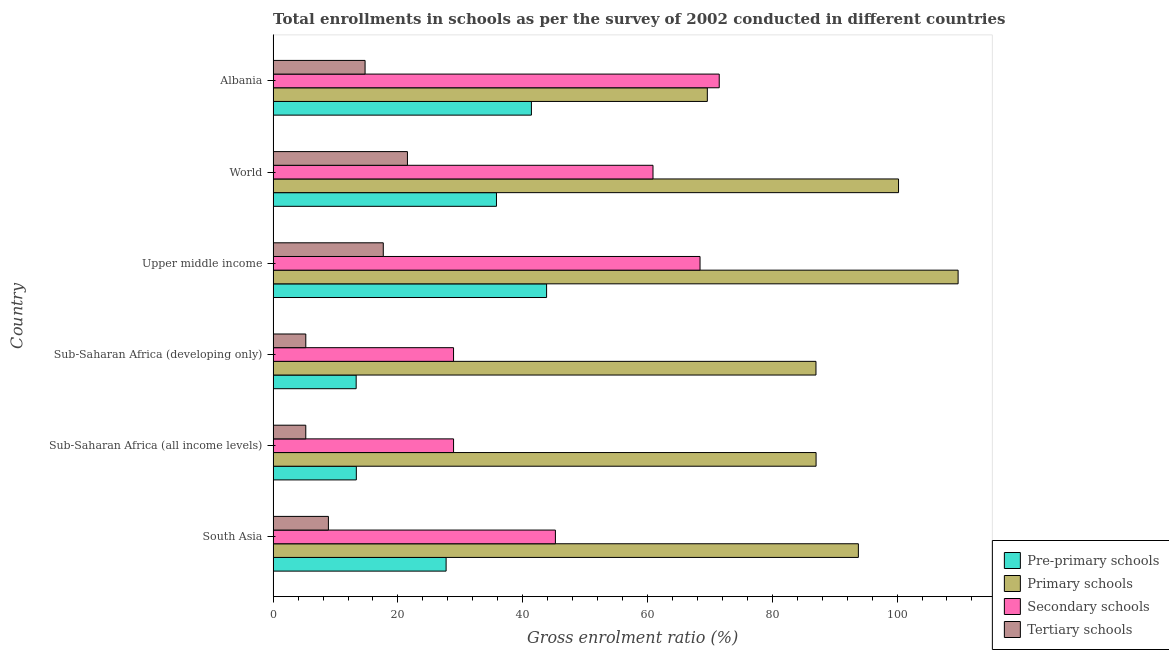How many different coloured bars are there?
Keep it short and to the point. 4. How many groups of bars are there?
Make the answer very short. 6. How many bars are there on the 2nd tick from the bottom?
Ensure brevity in your answer.  4. What is the label of the 1st group of bars from the top?
Keep it short and to the point. Albania. In how many cases, is the number of bars for a given country not equal to the number of legend labels?
Provide a short and direct response. 0. What is the gross enrolment ratio in primary schools in Upper middle income?
Provide a short and direct response. 109.78. Across all countries, what is the maximum gross enrolment ratio in secondary schools?
Your answer should be very brief. 71.5. Across all countries, what is the minimum gross enrolment ratio in secondary schools?
Offer a terse response. 28.92. In which country was the gross enrolment ratio in secondary schools maximum?
Your answer should be compact. Albania. In which country was the gross enrolment ratio in tertiary schools minimum?
Ensure brevity in your answer.  Sub-Saharan Africa (all income levels). What is the total gross enrolment ratio in primary schools in the graph?
Your answer should be very brief. 547.43. What is the difference between the gross enrolment ratio in tertiary schools in South Asia and that in Sub-Saharan Africa (developing only)?
Your answer should be very brief. 3.63. What is the difference between the gross enrolment ratio in primary schools in South Asia and the gross enrolment ratio in tertiary schools in Sub-Saharan Africa (developing only)?
Provide a short and direct response. 88.56. What is the average gross enrolment ratio in primary schools per country?
Provide a short and direct response. 91.24. What is the difference between the gross enrolment ratio in primary schools and gross enrolment ratio in tertiary schools in Sub-Saharan Africa (developing only)?
Provide a succinct answer. 81.77. In how many countries, is the gross enrolment ratio in secondary schools greater than 76 %?
Give a very brief answer. 0. What is the ratio of the gross enrolment ratio in tertiary schools in South Asia to that in Sub-Saharan Africa (developing only)?
Make the answer very short. 1.69. What is the difference between the highest and the second highest gross enrolment ratio in tertiary schools?
Your response must be concise. 3.87. What is the difference between the highest and the lowest gross enrolment ratio in pre-primary schools?
Ensure brevity in your answer.  30.52. In how many countries, is the gross enrolment ratio in secondary schools greater than the average gross enrolment ratio in secondary schools taken over all countries?
Make the answer very short. 3. Is the sum of the gross enrolment ratio in primary schools in South Asia and World greater than the maximum gross enrolment ratio in tertiary schools across all countries?
Provide a short and direct response. Yes. Is it the case that in every country, the sum of the gross enrolment ratio in tertiary schools and gross enrolment ratio in secondary schools is greater than the sum of gross enrolment ratio in primary schools and gross enrolment ratio in pre-primary schools?
Give a very brief answer. No. What does the 2nd bar from the top in Sub-Saharan Africa (developing only) represents?
Offer a very short reply. Secondary schools. What does the 3rd bar from the bottom in World represents?
Provide a short and direct response. Secondary schools. Is it the case that in every country, the sum of the gross enrolment ratio in pre-primary schools and gross enrolment ratio in primary schools is greater than the gross enrolment ratio in secondary schools?
Offer a terse response. Yes. Are all the bars in the graph horizontal?
Your answer should be compact. Yes. What is the difference between two consecutive major ticks on the X-axis?
Keep it short and to the point. 20. How many legend labels are there?
Your answer should be compact. 4. What is the title of the graph?
Your response must be concise. Total enrollments in schools as per the survey of 2002 conducted in different countries. Does "United States" appear as one of the legend labels in the graph?
Give a very brief answer. No. What is the Gross enrolment ratio (%) of Pre-primary schools in South Asia?
Your answer should be very brief. 27.72. What is the Gross enrolment ratio (%) of Primary schools in South Asia?
Your answer should be compact. 93.8. What is the Gross enrolment ratio (%) in Secondary schools in South Asia?
Provide a succinct answer. 45.24. What is the Gross enrolment ratio (%) in Tertiary schools in South Asia?
Offer a very short reply. 8.86. What is the Gross enrolment ratio (%) in Pre-primary schools in Sub-Saharan Africa (all income levels)?
Give a very brief answer. 13.34. What is the Gross enrolment ratio (%) of Primary schools in Sub-Saharan Africa (all income levels)?
Ensure brevity in your answer.  87.02. What is the Gross enrolment ratio (%) of Secondary schools in Sub-Saharan Africa (all income levels)?
Offer a very short reply. 28.92. What is the Gross enrolment ratio (%) of Tertiary schools in Sub-Saharan Africa (all income levels)?
Ensure brevity in your answer.  5.23. What is the Gross enrolment ratio (%) of Pre-primary schools in Sub-Saharan Africa (developing only)?
Ensure brevity in your answer.  13.31. What is the Gross enrolment ratio (%) of Primary schools in Sub-Saharan Africa (developing only)?
Your answer should be compact. 87. What is the Gross enrolment ratio (%) of Secondary schools in Sub-Saharan Africa (developing only)?
Ensure brevity in your answer.  28.92. What is the Gross enrolment ratio (%) of Tertiary schools in Sub-Saharan Africa (developing only)?
Give a very brief answer. 5.24. What is the Gross enrolment ratio (%) of Pre-primary schools in Upper middle income?
Provide a short and direct response. 43.83. What is the Gross enrolment ratio (%) of Primary schools in Upper middle income?
Ensure brevity in your answer.  109.78. What is the Gross enrolment ratio (%) in Secondary schools in Upper middle income?
Provide a short and direct response. 68.42. What is the Gross enrolment ratio (%) of Tertiary schools in Upper middle income?
Give a very brief answer. 17.65. What is the Gross enrolment ratio (%) in Pre-primary schools in World?
Ensure brevity in your answer.  35.8. What is the Gross enrolment ratio (%) of Primary schools in World?
Keep it short and to the point. 100.24. What is the Gross enrolment ratio (%) of Secondary schools in World?
Provide a short and direct response. 60.88. What is the Gross enrolment ratio (%) of Tertiary schools in World?
Ensure brevity in your answer.  21.53. What is the Gross enrolment ratio (%) of Pre-primary schools in Albania?
Offer a terse response. 41.4. What is the Gross enrolment ratio (%) in Primary schools in Albania?
Offer a terse response. 69.59. What is the Gross enrolment ratio (%) of Secondary schools in Albania?
Your response must be concise. 71.5. What is the Gross enrolment ratio (%) of Tertiary schools in Albania?
Keep it short and to the point. 14.74. Across all countries, what is the maximum Gross enrolment ratio (%) of Pre-primary schools?
Provide a succinct answer. 43.83. Across all countries, what is the maximum Gross enrolment ratio (%) in Primary schools?
Ensure brevity in your answer.  109.78. Across all countries, what is the maximum Gross enrolment ratio (%) in Secondary schools?
Your answer should be compact. 71.5. Across all countries, what is the maximum Gross enrolment ratio (%) in Tertiary schools?
Your answer should be compact. 21.53. Across all countries, what is the minimum Gross enrolment ratio (%) in Pre-primary schools?
Keep it short and to the point. 13.31. Across all countries, what is the minimum Gross enrolment ratio (%) of Primary schools?
Provide a short and direct response. 69.59. Across all countries, what is the minimum Gross enrolment ratio (%) in Secondary schools?
Ensure brevity in your answer.  28.92. Across all countries, what is the minimum Gross enrolment ratio (%) in Tertiary schools?
Your answer should be very brief. 5.23. What is the total Gross enrolment ratio (%) in Pre-primary schools in the graph?
Ensure brevity in your answer.  175.39. What is the total Gross enrolment ratio (%) in Primary schools in the graph?
Provide a succinct answer. 547.43. What is the total Gross enrolment ratio (%) of Secondary schools in the graph?
Ensure brevity in your answer.  303.88. What is the total Gross enrolment ratio (%) of Tertiary schools in the graph?
Make the answer very short. 73.25. What is the difference between the Gross enrolment ratio (%) in Pre-primary schools in South Asia and that in Sub-Saharan Africa (all income levels)?
Provide a succinct answer. 14.39. What is the difference between the Gross enrolment ratio (%) of Primary schools in South Asia and that in Sub-Saharan Africa (all income levels)?
Provide a short and direct response. 6.78. What is the difference between the Gross enrolment ratio (%) of Secondary schools in South Asia and that in Sub-Saharan Africa (all income levels)?
Your answer should be compact. 16.32. What is the difference between the Gross enrolment ratio (%) of Tertiary schools in South Asia and that in Sub-Saharan Africa (all income levels)?
Your answer should be very brief. 3.63. What is the difference between the Gross enrolment ratio (%) in Pre-primary schools in South Asia and that in Sub-Saharan Africa (developing only)?
Your response must be concise. 14.41. What is the difference between the Gross enrolment ratio (%) in Primary schools in South Asia and that in Sub-Saharan Africa (developing only)?
Keep it short and to the point. 6.8. What is the difference between the Gross enrolment ratio (%) in Secondary schools in South Asia and that in Sub-Saharan Africa (developing only)?
Your answer should be very brief. 16.32. What is the difference between the Gross enrolment ratio (%) in Tertiary schools in South Asia and that in Sub-Saharan Africa (developing only)?
Your response must be concise. 3.63. What is the difference between the Gross enrolment ratio (%) in Pre-primary schools in South Asia and that in Upper middle income?
Keep it short and to the point. -16.11. What is the difference between the Gross enrolment ratio (%) of Primary schools in South Asia and that in Upper middle income?
Keep it short and to the point. -15.98. What is the difference between the Gross enrolment ratio (%) of Secondary schools in South Asia and that in Upper middle income?
Give a very brief answer. -23.18. What is the difference between the Gross enrolment ratio (%) of Tertiary schools in South Asia and that in Upper middle income?
Ensure brevity in your answer.  -8.79. What is the difference between the Gross enrolment ratio (%) in Pre-primary schools in South Asia and that in World?
Your answer should be very brief. -8.07. What is the difference between the Gross enrolment ratio (%) in Primary schools in South Asia and that in World?
Offer a terse response. -6.44. What is the difference between the Gross enrolment ratio (%) in Secondary schools in South Asia and that in World?
Provide a short and direct response. -15.64. What is the difference between the Gross enrolment ratio (%) of Tertiary schools in South Asia and that in World?
Provide a short and direct response. -12.66. What is the difference between the Gross enrolment ratio (%) of Pre-primary schools in South Asia and that in Albania?
Ensure brevity in your answer.  -13.67. What is the difference between the Gross enrolment ratio (%) in Primary schools in South Asia and that in Albania?
Keep it short and to the point. 24.21. What is the difference between the Gross enrolment ratio (%) of Secondary schools in South Asia and that in Albania?
Provide a short and direct response. -26.26. What is the difference between the Gross enrolment ratio (%) of Tertiary schools in South Asia and that in Albania?
Give a very brief answer. -5.88. What is the difference between the Gross enrolment ratio (%) in Pre-primary schools in Sub-Saharan Africa (all income levels) and that in Sub-Saharan Africa (developing only)?
Your answer should be compact. 0.03. What is the difference between the Gross enrolment ratio (%) of Primary schools in Sub-Saharan Africa (all income levels) and that in Sub-Saharan Africa (developing only)?
Give a very brief answer. 0.02. What is the difference between the Gross enrolment ratio (%) in Secondary schools in Sub-Saharan Africa (all income levels) and that in Sub-Saharan Africa (developing only)?
Provide a short and direct response. 0. What is the difference between the Gross enrolment ratio (%) of Tertiary schools in Sub-Saharan Africa (all income levels) and that in Sub-Saharan Africa (developing only)?
Your response must be concise. -0. What is the difference between the Gross enrolment ratio (%) of Pre-primary schools in Sub-Saharan Africa (all income levels) and that in Upper middle income?
Offer a terse response. -30.49. What is the difference between the Gross enrolment ratio (%) in Primary schools in Sub-Saharan Africa (all income levels) and that in Upper middle income?
Provide a succinct answer. -22.76. What is the difference between the Gross enrolment ratio (%) in Secondary schools in Sub-Saharan Africa (all income levels) and that in Upper middle income?
Make the answer very short. -39.5. What is the difference between the Gross enrolment ratio (%) in Tertiary schools in Sub-Saharan Africa (all income levels) and that in Upper middle income?
Provide a short and direct response. -12.42. What is the difference between the Gross enrolment ratio (%) in Pre-primary schools in Sub-Saharan Africa (all income levels) and that in World?
Ensure brevity in your answer.  -22.46. What is the difference between the Gross enrolment ratio (%) in Primary schools in Sub-Saharan Africa (all income levels) and that in World?
Make the answer very short. -13.22. What is the difference between the Gross enrolment ratio (%) in Secondary schools in Sub-Saharan Africa (all income levels) and that in World?
Your answer should be very brief. -31.96. What is the difference between the Gross enrolment ratio (%) in Tertiary schools in Sub-Saharan Africa (all income levels) and that in World?
Provide a succinct answer. -16.29. What is the difference between the Gross enrolment ratio (%) in Pre-primary schools in Sub-Saharan Africa (all income levels) and that in Albania?
Offer a terse response. -28.06. What is the difference between the Gross enrolment ratio (%) in Primary schools in Sub-Saharan Africa (all income levels) and that in Albania?
Give a very brief answer. 17.43. What is the difference between the Gross enrolment ratio (%) of Secondary schools in Sub-Saharan Africa (all income levels) and that in Albania?
Ensure brevity in your answer.  -42.58. What is the difference between the Gross enrolment ratio (%) in Tertiary schools in Sub-Saharan Africa (all income levels) and that in Albania?
Keep it short and to the point. -9.5. What is the difference between the Gross enrolment ratio (%) in Pre-primary schools in Sub-Saharan Africa (developing only) and that in Upper middle income?
Your answer should be very brief. -30.52. What is the difference between the Gross enrolment ratio (%) of Primary schools in Sub-Saharan Africa (developing only) and that in Upper middle income?
Keep it short and to the point. -22.78. What is the difference between the Gross enrolment ratio (%) in Secondary schools in Sub-Saharan Africa (developing only) and that in Upper middle income?
Ensure brevity in your answer.  -39.51. What is the difference between the Gross enrolment ratio (%) in Tertiary schools in Sub-Saharan Africa (developing only) and that in Upper middle income?
Your answer should be very brief. -12.42. What is the difference between the Gross enrolment ratio (%) in Pre-primary schools in Sub-Saharan Africa (developing only) and that in World?
Provide a succinct answer. -22.49. What is the difference between the Gross enrolment ratio (%) in Primary schools in Sub-Saharan Africa (developing only) and that in World?
Ensure brevity in your answer.  -13.23. What is the difference between the Gross enrolment ratio (%) in Secondary schools in Sub-Saharan Africa (developing only) and that in World?
Give a very brief answer. -31.97. What is the difference between the Gross enrolment ratio (%) in Tertiary schools in Sub-Saharan Africa (developing only) and that in World?
Your answer should be very brief. -16.29. What is the difference between the Gross enrolment ratio (%) in Pre-primary schools in Sub-Saharan Africa (developing only) and that in Albania?
Your answer should be very brief. -28.09. What is the difference between the Gross enrolment ratio (%) of Primary schools in Sub-Saharan Africa (developing only) and that in Albania?
Give a very brief answer. 17.41. What is the difference between the Gross enrolment ratio (%) of Secondary schools in Sub-Saharan Africa (developing only) and that in Albania?
Provide a short and direct response. -42.58. What is the difference between the Gross enrolment ratio (%) of Tertiary schools in Sub-Saharan Africa (developing only) and that in Albania?
Offer a terse response. -9.5. What is the difference between the Gross enrolment ratio (%) of Pre-primary schools in Upper middle income and that in World?
Provide a succinct answer. 8.04. What is the difference between the Gross enrolment ratio (%) in Primary schools in Upper middle income and that in World?
Provide a succinct answer. 9.55. What is the difference between the Gross enrolment ratio (%) in Secondary schools in Upper middle income and that in World?
Keep it short and to the point. 7.54. What is the difference between the Gross enrolment ratio (%) of Tertiary schools in Upper middle income and that in World?
Your answer should be compact. -3.87. What is the difference between the Gross enrolment ratio (%) in Pre-primary schools in Upper middle income and that in Albania?
Keep it short and to the point. 2.43. What is the difference between the Gross enrolment ratio (%) in Primary schools in Upper middle income and that in Albania?
Your response must be concise. 40.19. What is the difference between the Gross enrolment ratio (%) of Secondary schools in Upper middle income and that in Albania?
Give a very brief answer. -3.08. What is the difference between the Gross enrolment ratio (%) of Tertiary schools in Upper middle income and that in Albania?
Ensure brevity in your answer.  2.92. What is the difference between the Gross enrolment ratio (%) of Pre-primary schools in World and that in Albania?
Your answer should be compact. -5.6. What is the difference between the Gross enrolment ratio (%) of Primary schools in World and that in Albania?
Your response must be concise. 30.64. What is the difference between the Gross enrolment ratio (%) in Secondary schools in World and that in Albania?
Provide a short and direct response. -10.62. What is the difference between the Gross enrolment ratio (%) of Tertiary schools in World and that in Albania?
Offer a terse response. 6.79. What is the difference between the Gross enrolment ratio (%) in Pre-primary schools in South Asia and the Gross enrolment ratio (%) in Primary schools in Sub-Saharan Africa (all income levels)?
Provide a succinct answer. -59.3. What is the difference between the Gross enrolment ratio (%) of Pre-primary schools in South Asia and the Gross enrolment ratio (%) of Secondary schools in Sub-Saharan Africa (all income levels)?
Keep it short and to the point. -1.2. What is the difference between the Gross enrolment ratio (%) of Pre-primary schools in South Asia and the Gross enrolment ratio (%) of Tertiary schools in Sub-Saharan Africa (all income levels)?
Give a very brief answer. 22.49. What is the difference between the Gross enrolment ratio (%) in Primary schools in South Asia and the Gross enrolment ratio (%) in Secondary schools in Sub-Saharan Africa (all income levels)?
Keep it short and to the point. 64.88. What is the difference between the Gross enrolment ratio (%) in Primary schools in South Asia and the Gross enrolment ratio (%) in Tertiary schools in Sub-Saharan Africa (all income levels)?
Your answer should be compact. 88.56. What is the difference between the Gross enrolment ratio (%) in Secondary schools in South Asia and the Gross enrolment ratio (%) in Tertiary schools in Sub-Saharan Africa (all income levels)?
Make the answer very short. 40.01. What is the difference between the Gross enrolment ratio (%) of Pre-primary schools in South Asia and the Gross enrolment ratio (%) of Primary schools in Sub-Saharan Africa (developing only)?
Provide a succinct answer. -59.28. What is the difference between the Gross enrolment ratio (%) in Pre-primary schools in South Asia and the Gross enrolment ratio (%) in Secondary schools in Sub-Saharan Africa (developing only)?
Ensure brevity in your answer.  -1.19. What is the difference between the Gross enrolment ratio (%) in Pre-primary schools in South Asia and the Gross enrolment ratio (%) in Tertiary schools in Sub-Saharan Africa (developing only)?
Your answer should be very brief. 22.49. What is the difference between the Gross enrolment ratio (%) of Primary schools in South Asia and the Gross enrolment ratio (%) of Secondary schools in Sub-Saharan Africa (developing only)?
Give a very brief answer. 64.88. What is the difference between the Gross enrolment ratio (%) of Primary schools in South Asia and the Gross enrolment ratio (%) of Tertiary schools in Sub-Saharan Africa (developing only)?
Offer a very short reply. 88.56. What is the difference between the Gross enrolment ratio (%) in Secondary schools in South Asia and the Gross enrolment ratio (%) in Tertiary schools in Sub-Saharan Africa (developing only)?
Ensure brevity in your answer.  40.01. What is the difference between the Gross enrolment ratio (%) in Pre-primary schools in South Asia and the Gross enrolment ratio (%) in Primary schools in Upper middle income?
Your answer should be very brief. -82.06. What is the difference between the Gross enrolment ratio (%) in Pre-primary schools in South Asia and the Gross enrolment ratio (%) in Secondary schools in Upper middle income?
Make the answer very short. -40.7. What is the difference between the Gross enrolment ratio (%) in Pre-primary schools in South Asia and the Gross enrolment ratio (%) in Tertiary schools in Upper middle income?
Offer a terse response. 10.07. What is the difference between the Gross enrolment ratio (%) in Primary schools in South Asia and the Gross enrolment ratio (%) in Secondary schools in Upper middle income?
Ensure brevity in your answer.  25.38. What is the difference between the Gross enrolment ratio (%) in Primary schools in South Asia and the Gross enrolment ratio (%) in Tertiary schools in Upper middle income?
Offer a terse response. 76.14. What is the difference between the Gross enrolment ratio (%) in Secondary schools in South Asia and the Gross enrolment ratio (%) in Tertiary schools in Upper middle income?
Ensure brevity in your answer.  27.59. What is the difference between the Gross enrolment ratio (%) of Pre-primary schools in South Asia and the Gross enrolment ratio (%) of Primary schools in World?
Keep it short and to the point. -72.51. What is the difference between the Gross enrolment ratio (%) in Pre-primary schools in South Asia and the Gross enrolment ratio (%) in Secondary schools in World?
Keep it short and to the point. -33.16. What is the difference between the Gross enrolment ratio (%) of Pre-primary schools in South Asia and the Gross enrolment ratio (%) of Tertiary schools in World?
Provide a short and direct response. 6.2. What is the difference between the Gross enrolment ratio (%) of Primary schools in South Asia and the Gross enrolment ratio (%) of Secondary schools in World?
Offer a terse response. 32.92. What is the difference between the Gross enrolment ratio (%) in Primary schools in South Asia and the Gross enrolment ratio (%) in Tertiary schools in World?
Keep it short and to the point. 72.27. What is the difference between the Gross enrolment ratio (%) in Secondary schools in South Asia and the Gross enrolment ratio (%) in Tertiary schools in World?
Your response must be concise. 23.72. What is the difference between the Gross enrolment ratio (%) of Pre-primary schools in South Asia and the Gross enrolment ratio (%) of Primary schools in Albania?
Ensure brevity in your answer.  -41.87. What is the difference between the Gross enrolment ratio (%) in Pre-primary schools in South Asia and the Gross enrolment ratio (%) in Secondary schools in Albania?
Your answer should be compact. -43.77. What is the difference between the Gross enrolment ratio (%) in Pre-primary schools in South Asia and the Gross enrolment ratio (%) in Tertiary schools in Albania?
Ensure brevity in your answer.  12.99. What is the difference between the Gross enrolment ratio (%) of Primary schools in South Asia and the Gross enrolment ratio (%) of Secondary schools in Albania?
Your answer should be compact. 22.3. What is the difference between the Gross enrolment ratio (%) of Primary schools in South Asia and the Gross enrolment ratio (%) of Tertiary schools in Albania?
Your answer should be very brief. 79.06. What is the difference between the Gross enrolment ratio (%) of Secondary schools in South Asia and the Gross enrolment ratio (%) of Tertiary schools in Albania?
Your answer should be very brief. 30.5. What is the difference between the Gross enrolment ratio (%) of Pre-primary schools in Sub-Saharan Africa (all income levels) and the Gross enrolment ratio (%) of Primary schools in Sub-Saharan Africa (developing only)?
Make the answer very short. -73.67. What is the difference between the Gross enrolment ratio (%) of Pre-primary schools in Sub-Saharan Africa (all income levels) and the Gross enrolment ratio (%) of Secondary schools in Sub-Saharan Africa (developing only)?
Offer a terse response. -15.58. What is the difference between the Gross enrolment ratio (%) in Pre-primary schools in Sub-Saharan Africa (all income levels) and the Gross enrolment ratio (%) in Tertiary schools in Sub-Saharan Africa (developing only)?
Make the answer very short. 8.1. What is the difference between the Gross enrolment ratio (%) in Primary schools in Sub-Saharan Africa (all income levels) and the Gross enrolment ratio (%) in Secondary schools in Sub-Saharan Africa (developing only)?
Your answer should be very brief. 58.1. What is the difference between the Gross enrolment ratio (%) of Primary schools in Sub-Saharan Africa (all income levels) and the Gross enrolment ratio (%) of Tertiary schools in Sub-Saharan Africa (developing only)?
Offer a very short reply. 81.78. What is the difference between the Gross enrolment ratio (%) in Secondary schools in Sub-Saharan Africa (all income levels) and the Gross enrolment ratio (%) in Tertiary schools in Sub-Saharan Africa (developing only)?
Keep it short and to the point. 23.68. What is the difference between the Gross enrolment ratio (%) in Pre-primary schools in Sub-Saharan Africa (all income levels) and the Gross enrolment ratio (%) in Primary schools in Upper middle income?
Ensure brevity in your answer.  -96.45. What is the difference between the Gross enrolment ratio (%) in Pre-primary schools in Sub-Saharan Africa (all income levels) and the Gross enrolment ratio (%) in Secondary schools in Upper middle income?
Offer a terse response. -55.09. What is the difference between the Gross enrolment ratio (%) in Pre-primary schools in Sub-Saharan Africa (all income levels) and the Gross enrolment ratio (%) in Tertiary schools in Upper middle income?
Give a very brief answer. -4.32. What is the difference between the Gross enrolment ratio (%) of Primary schools in Sub-Saharan Africa (all income levels) and the Gross enrolment ratio (%) of Secondary schools in Upper middle income?
Offer a terse response. 18.6. What is the difference between the Gross enrolment ratio (%) of Primary schools in Sub-Saharan Africa (all income levels) and the Gross enrolment ratio (%) of Tertiary schools in Upper middle income?
Your response must be concise. 69.36. What is the difference between the Gross enrolment ratio (%) of Secondary schools in Sub-Saharan Africa (all income levels) and the Gross enrolment ratio (%) of Tertiary schools in Upper middle income?
Provide a short and direct response. 11.27. What is the difference between the Gross enrolment ratio (%) of Pre-primary schools in Sub-Saharan Africa (all income levels) and the Gross enrolment ratio (%) of Primary schools in World?
Your answer should be compact. -86.9. What is the difference between the Gross enrolment ratio (%) in Pre-primary schools in Sub-Saharan Africa (all income levels) and the Gross enrolment ratio (%) in Secondary schools in World?
Offer a terse response. -47.55. What is the difference between the Gross enrolment ratio (%) of Pre-primary schools in Sub-Saharan Africa (all income levels) and the Gross enrolment ratio (%) of Tertiary schools in World?
Provide a short and direct response. -8.19. What is the difference between the Gross enrolment ratio (%) in Primary schools in Sub-Saharan Africa (all income levels) and the Gross enrolment ratio (%) in Secondary schools in World?
Provide a short and direct response. 26.14. What is the difference between the Gross enrolment ratio (%) in Primary schools in Sub-Saharan Africa (all income levels) and the Gross enrolment ratio (%) in Tertiary schools in World?
Make the answer very short. 65.49. What is the difference between the Gross enrolment ratio (%) of Secondary schools in Sub-Saharan Africa (all income levels) and the Gross enrolment ratio (%) of Tertiary schools in World?
Your response must be concise. 7.39. What is the difference between the Gross enrolment ratio (%) in Pre-primary schools in Sub-Saharan Africa (all income levels) and the Gross enrolment ratio (%) in Primary schools in Albania?
Ensure brevity in your answer.  -56.26. What is the difference between the Gross enrolment ratio (%) in Pre-primary schools in Sub-Saharan Africa (all income levels) and the Gross enrolment ratio (%) in Secondary schools in Albania?
Provide a succinct answer. -58.16. What is the difference between the Gross enrolment ratio (%) of Pre-primary schools in Sub-Saharan Africa (all income levels) and the Gross enrolment ratio (%) of Tertiary schools in Albania?
Provide a short and direct response. -1.4. What is the difference between the Gross enrolment ratio (%) of Primary schools in Sub-Saharan Africa (all income levels) and the Gross enrolment ratio (%) of Secondary schools in Albania?
Keep it short and to the point. 15.52. What is the difference between the Gross enrolment ratio (%) in Primary schools in Sub-Saharan Africa (all income levels) and the Gross enrolment ratio (%) in Tertiary schools in Albania?
Offer a terse response. 72.28. What is the difference between the Gross enrolment ratio (%) of Secondary schools in Sub-Saharan Africa (all income levels) and the Gross enrolment ratio (%) of Tertiary schools in Albania?
Keep it short and to the point. 14.18. What is the difference between the Gross enrolment ratio (%) in Pre-primary schools in Sub-Saharan Africa (developing only) and the Gross enrolment ratio (%) in Primary schools in Upper middle income?
Offer a very short reply. -96.47. What is the difference between the Gross enrolment ratio (%) of Pre-primary schools in Sub-Saharan Africa (developing only) and the Gross enrolment ratio (%) of Secondary schools in Upper middle income?
Provide a short and direct response. -55.11. What is the difference between the Gross enrolment ratio (%) of Pre-primary schools in Sub-Saharan Africa (developing only) and the Gross enrolment ratio (%) of Tertiary schools in Upper middle income?
Your answer should be very brief. -4.34. What is the difference between the Gross enrolment ratio (%) of Primary schools in Sub-Saharan Africa (developing only) and the Gross enrolment ratio (%) of Secondary schools in Upper middle income?
Your answer should be compact. 18.58. What is the difference between the Gross enrolment ratio (%) of Primary schools in Sub-Saharan Africa (developing only) and the Gross enrolment ratio (%) of Tertiary schools in Upper middle income?
Your response must be concise. 69.35. What is the difference between the Gross enrolment ratio (%) in Secondary schools in Sub-Saharan Africa (developing only) and the Gross enrolment ratio (%) in Tertiary schools in Upper middle income?
Offer a terse response. 11.26. What is the difference between the Gross enrolment ratio (%) in Pre-primary schools in Sub-Saharan Africa (developing only) and the Gross enrolment ratio (%) in Primary schools in World?
Provide a succinct answer. -86.93. What is the difference between the Gross enrolment ratio (%) of Pre-primary schools in Sub-Saharan Africa (developing only) and the Gross enrolment ratio (%) of Secondary schools in World?
Provide a succinct answer. -47.57. What is the difference between the Gross enrolment ratio (%) of Pre-primary schools in Sub-Saharan Africa (developing only) and the Gross enrolment ratio (%) of Tertiary schools in World?
Give a very brief answer. -8.22. What is the difference between the Gross enrolment ratio (%) in Primary schools in Sub-Saharan Africa (developing only) and the Gross enrolment ratio (%) in Secondary schools in World?
Provide a short and direct response. 26.12. What is the difference between the Gross enrolment ratio (%) in Primary schools in Sub-Saharan Africa (developing only) and the Gross enrolment ratio (%) in Tertiary schools in World?
Provide a short and direct response. 65.48. What is the difference between the Gross enrolment ratio (%) in Secondary schools in Sub-Saharan Africa (developing only) and the Gross enrolment ratio (%) in Tertiary schools in World?
Offer a very short reply. 7.39. What is the difference between the Gross enrolment ratio (%) in Pre-primary schools in Sub-Saharan Africa (developing only) and the Gross enrolment ratio (%) in Primary schools in Albania?
Keep it short and to the point. -56.28. What is the difference between the Gross enrolment ratio (%) of Pre-primary schools in Sub-Saharan Africa (developing only) and the Gross enrolment ratio (%) of Secondary schools in Albania?
Provide a short and direct response. -58.19. What is the difference between the Gross enrolment ratio (%) of Pre-primary schools in Sub-Saharan Africa (developing only) and the Gross enrolment ratio (%) of Tertiary schools in Albania?
Provide a short and direct response. -1.43. What is the difference between the Gross enrolment ratio (%) of Primary schools in Sub-Saharan Africa (developing only) and the Gross enrolment ratio (%) of Secondary schools in Albania?
Give a very brief answer. 15.5. What is the difference between the Gross enrolment ratio (%) of Primary schools in Sub-Saharan Africa (developing only) and the Gross enrolment ratio (%) of Tertiary schools in Albania?
Keep it short and to the point. 72.26. What is the difference between the Gross enrolment ratio (%) in Secondary schools in Sub-Saharan Africa (developing only) and the Gross enrolment ratio (%) in Tertiary schools in Albania?
Keep it short and to the point. 14.18. What is the difference between the Gross enrolment ratio (%) in Pre-primary schools in Upper middle income and the Gross enrolment ratio (%) in Primary schools in World?
Ensure brevity in your answer.  -56.41. What is the difference between the Gross enrolment ratio (%) in Pre-primary schools in Upper middle income and the Gross enrolment ratio (%) in Secondary schools in World?
Provide a succinct answer. -17.05. What is the difference between the Gross enrolment ratio (%) of Pre-primary schools in Upper middle income and the Gross enrolment ratio (%) of Tertiary schools in World?
Your answer should be compact. 22.3. What is the difference between the Gross enrolment ratio (%) in Primary schools in Upper middle income and the Gross enrolment ratio (%) in Secondary schools in World?
Offer a very short reply. 48.9. What is the difference between the Gross enrolment ratio (%) in Primary schools in Upper middle income and the Gross enrolment ratio (%) in Tertiary schools in World?
Your answer should be very brief. 88.26. What is the difference between the Gross enrolment ratio (%) in Secondary schools in Upper middle income and the Gross enrolment ratio (%) in Tertiary schools in World?
Keep it short and to the point. 46.9. What is the difference between the Gross enrolment ratio (%) of Pre-primary schools in Upper middle income and the Gross enrolment ratio (%) of Primary schools in Albania?
Your response must be concise. -25.76. What is the difference between the Gross enrolment ratio (%) in Pre-primary schools in Upper middle income and the Gross enrolment ratio (%) in Secondary schools in Albania?
Your answer should be very brief. -27.67. What is the difference between the Gross enrolment ratio (%) of Pre-primary schools in Upper middle income and the Gross enrolment ratio (%) of Tertiary schools in Albania?
Offer a terse response. 29.09. What is the difference between the Gross enrolment ratio (%) in Primary schools in Upper middle income and the Gross enrolment ratio (%) in Secondary schools in Albania?
Your answer should be very brief. 38.28. What is the difference between the Gross enrolment ratio (%) of Primary schools in Upper middle income and the Gross enrolment ratio (%) of Tertiary schools in Albania?
Give a very brief answer. 95.04. What is the difference between the Gross enrolment ratio (%) of Secondary schools in Upper middle income and the Gross enrolment ratio (%) of Tertiary schools in Albania?
Give a very brief answer. 53.68. What is the difference between the Gross enrolment ratio (%) of Pre-primary schools in World and the Gross enrolment ratio (%) of Primary schools in Albania?
Offer a terse response. -33.8. What is the difference between the Gross enrolment ratio (%) of Pre-primary schools in World and the Gross enrolment ratio (%) of Secondary schools in Albania?
Provide a short and direct response. -35.7. What is the difference between the Gross enrolment ratio (%) of Pre-primary schools in World and the Gross enrolment ratio (%) of Tertiary schools in Albania?
Keep it short and to the point. 21.06. What is the difference between the Gross enrolment ratio (%) of Primary schools in World and the Gross enrolment ratio (%) of Secondary schools in Albania?
Your answer should be compact. 28.74. What is the difference between the Gross enrolment ratio (%) of Primary schools in World and the Gross enrolment ratio (%) of Tertiary schools in Albania?
Offer a very short reply. 85.5. What is the difference between the Gross enrolment ratio (%) of Secondary schools in World and the Gross enrolment ratio (%) of Tertiary schools in Albania?
Offer a terse response. 46.14. What is the average Gross enrolment ratio (%) of Pre-primary schools per country?
Offer a very short reply. 29.23. What is the average Gross enrolment ratio (%) in Primary schools per country?
Your answer should be very brief. 91.24. What is the average Gross enrolment ratio (%) in Secondary schools per country?
Provide a succinct answer. 50.65. What is the average Gross enrolment ratio (%) of Tertiary schools per country?
Ensure brevity in your answer.  12.21. What is the difference between the Gross enrolment ratio (%) in Pre-primary schools and Gross enrolment ratio (%) in Primary schools in South Asia?
Provide a succinct answer. -66.08. What is the difference between the Gross enrolment ratio (%) in Pre-primary schools and Gross enrolment ratio (%) in Secondary schools in South Asia?
Provide a succinct answer. -17.52. What is the difference between the Gross enrolment ratio (%) of Pre-primary schools and Gross enrolment ratio (%) of Tertiary schools in South Asia?
Ensure brevity in your answer.  18.86. What is the difference between the Gross enrolment ratio (%) in Primary schools and Gross enrolment ratio (%) in Secondary schools in South Asia?
Keep it short and to the point. 48.56. What is the difference between the Gross enrolment ratio (%) in Primary schools and Gross enrolment ratio (%) in Tertiary schools in South Asia?
Provide a succinct answer. 84.94. What is the difference between the Gross enrolment ratio (%) of Secondary schools and Gross enrolment ratio (%) of Tertiary schools in South Asia?
Offer a very short reply. 36.38. What is the difference between the Gross enrolment ratio (%) in Pre-primary schools and Gross enrolment ratio (%) in Primary schools in Sub-Saharan Africa (all income levels)?
Offer a very short reply. -73.68. What is the difference between the Gross enrolment ratio (%) in Pre-primary schools and Gross enrolment ratio (%) in Secondary schools in Sub-Saharan Africa (all income levels)?
Your answer should be compact. -15.58. What is the difference between the Gross enrolment ratio (%) of Pre-primary schools and Gross enrolment ratio (%) of Tertiary schools in Sub-Saharan Africa (all income levels)?
Give a very brief answer. 8.1. What is the difference between the Gross enrolment ratio (%) of Primary schools and Gross enrolment ratio (%) of Secondary schools in Sub-Saharan Africa (all income levels)?
Offer a terse response. 58.1. What is the difference between the Gross enrolment ratio (%) of Primary schools and Gross enrolment ratio (%) of Tertiary schools in Sub-Saharan Africa (all income levels)?
Provide a succinct answer. 81.78. What is the difference between the Gross enrolment ratio (%) of Secondary schools and Gross enrolment ratio (%) of Tertiary schools in Sub-Saharan Africa (all income levels)?
Offer a very short reply. 23.69. What is the difference between the Gross enrolment ratio (%) in Pre-primary schools and Gross enrolment ratio (%) in Primary schools in Sub-Saharan Africa (developing only)?
Offer a terse response. -73.69. What is the difference between the Gross enrolment ratio (%) in Pre-primary schools and Gross enrolment ratio (%) in Secondary schools in Sub-Saharan Africa (developing only)?
Your answer should be very brief. -15.61. What is the difference between the Gross enrolment ratio (%) in Pre-primary schools and Gross enrolment ratio (%) in Tertiary schools in Sub-Saharan Africa (developing only)?
Keep it short and to the point. 8.07. What is the difference between the Gross enrolment ratio (%) of Primary schools and Gross enrolment ratio (%) of Secondary schools in Sub-Saharan Africa (developing only)?
Ensure brevity in your answer.  58.09. What is the difference between the Gross enrolment ratio (%) of Primary schools and Gross enrolment ratio (%) of Tertiary schools in Sub-Saharan Africa (developing only)?
Keep it short and to the point. 81.77. What is the difference between the Gross enrolment ratio (%) in Secondary schools and Gross enrolment ratio (%) in Tertiary schools in Sub-Saharan Africa (developing only)?
Your response must be concise. 23.68. What is the difference between the Gross enrolment ratio (%) of Pre-primary schools and Gross enrolment ratio (%) of Primary schools in Upper middle income?
Provide a succinct answer. -65.95. What is the difference between the Gross enrolment ratio (%) in Pre-primary schools and Gross enrolment ratio (%) in Secondary schools in Upper middle income?
Your answer should be compact. -24.59. What is the difference between the Gross enrolment ratio (%) of Pre-primary schools and Gross enrolment ratio (%) of Tertiary schools in Upper middle income?
Ensure brevity in your answer.  26.18. What is the difference between the Gross enrolment ratio (%) in Primary schools and Gross enrolment ratio (%) in Secondary schools in Upper middle income?
Ensure brevity in your answer.  41.36. What is the difference between the Gross enrolment ratio (%) in Primary schools and Gross enrolment ratio (%) in Tertiary schools in Upper middle income?
Offer a very short reply. 92.13. What is the difference between the Gross enrolment ratio (%) of Secondary schools and Gross enrolment ratio (%) of Tertiary schools in Upper middle income?
Ensure brevity in your answer.  50.77. What is the difference between the Gross enrolment ratio (%) in Pre-primary schools and Gross enrolment ratio (%) in Primary schools in World?
Give a very brief answer. -64.44. What is the difference between the Gross enrolment ratio (%) of Pre-primary schools and Gross enrolment ratio (%) of Secondary schools in World?
Give a very brief answer. -25.09. What is the difference between the Gross enrolment ratio (%) in Pre-primary schools and Gross enrolment ratio (%) in Tertiary schools in World?
Offer a terse response. 14.27. What is the difference between the Gross enrolment ratio (%) of Primary schools and Gross enrolment ratio (%) of Secondary schools in World?
Provide a short and direct response. 39.35. What is the difference between the Gross enrolment ratio (%) of Primary schools and Gross enrolment ratio (%) of Tertiary schools in World?
Make the answer very short. 78.71. What is the difference between the Gross enrolment ratio (%) in Secondary schools and Gross enrolment ratio (%) in Tertiary schools in World?
Ensure brevity in your answer.  39.36. What is the difference between the Gross enrolment ratio (%) of Pre-primary schools and Gross enrolment ratio (%) of Primary schools in Albania?
Provide a short and direct response. -28.2. What is the difference between the Gross enrolment ratio (%) of Pre-primary schools and Gross enrolment ratio (%) of Secondary schools in Albania?
Give a very brief answer. -30.1. What is the difference between the Gross enrolment ratio (%) in Pre-primary schools and Gross enrolment ratio (%) in Tertiary schools in Albania?
Keep it short and to the point. 26.66. What is the difference between the Gross enrolment ratio (%) in Primary schools and Gross enrolment ratio (%) in Secondary schools in Albania?
Provide a succinct answer. -1.91. What is the difference between the Gross enrolment ratio (%) in Primary schools and Gross enrolment ratio (%) in Tertiary schools in Albania?
Ensure brevity in your answer.  54.85. What is the difference between the Gross enrolment ratio (%) in Secondary schools and Gross enrolment ratio (%) in Tertiary schools in Albania?
Offer a terse response. 56.76. What is the ratio of the Gross enrolment ratio (%) of Pre-primary schools in South Asia to that in Sub-Saharan Africa (all income levels)?
Ensure brevity in your answer.  2.08. What is the ratio of the Gross enrolment ratio (%) in Primary schools in South Asia to that in Sub-Saharan Africa (all income levels)?
Your answer should be compact. 1.08. What is the ratio of the Gross enrolment ratio (%) of Secondary schools in South Asia to that in Sub-Saharan Africa (all income levels)?
Make the answer very short. 1.56. What is the ratio of the Gross enrolment ratio (%) in Tertiary schools in South Asia to that in Sub-Saharan Africa (all income levels)?
Offer a terse response. 1.69. What is the ratio of the Gross enrolment ratio (%) in Pre-primary schools in South Asia to that in Sub-Saharan Africa (developing only)?
Provide a succinct answer. 2.08. What is the ratio of the Gross enrolment ratio (%) in Primary schools in South Asia to that in Sub-Saharan Africa (developing only)?
Offer a very short reply. 1.08. What is the ratio of the Gross enrolment ratio (%) in Secondary schools in South Asia to that in Sub-Saharan Africa (developing only)?
Provide a short and direct response. 1.56. What is the ratio of the Gross enrolment ratio (%) of Tertiary schools in South Asia to that in Sub-Saharan Africa (developing only)?
Your response must be concise. 1.69. What is the ratio of the Gross enrolment ratio (%) of Pre-primary schools in South Asia to that in Upper middle income?
Ensure brevity in your answer.  0.63. What is the ratio of the Gross enrolment ratio (%) of Primary schools in South Asia to that in Upper middle income?
Offer a terse response. 0.85. What is the ratio of the Gross enrolment ratio (%) in Secondary schools in South Asia to that in Upper middle income?
Ensure brevity in your answer.  0.66. What is the ratio of the Gross enrolment ratio (%) of Tertiary schools in South Asia to that in Upper middle income?
Give a very brief answer. 0.5. What is the ratio of the Gross enrolment ratio (%) of Pre-primary schools in South Asia to that in World?
Offer a terse response. 0.77. What is the ratio of the Gross enrolment ratio (%) in Primary schools in South Asia to that in World?
Your response must be concise. 0.94. What is the ratio of the Gross enrolment ratio (%) of Secondary schools in South Asia to that in World?
Provide a short and direct response. 0.74. What is the ratio of the Gross enrolment ratio (%) of Tertiary schools in South Asia to that in World?
Your answer should be very brief. 0.41. What is the ratio of the Gross enrolment ratio (%) of Pre-primary schools in South Asia to that in Albania?
Keep it short and to the point. 0.67. What is the ratio of the Gross enrolment ratio (%) in Primary schools in South Asia to that in Albania?
Provide a succinct answer. 1.35. What is the ratio of the Gross enrolment ratio (%) in Secondary schools in South Asia to that in Albania?
Keep it short and to the point. 0.63. What is the ratio of the Gross enrolment ratio (%) in Tertiary schools in South Asia to that in Albania?
Offer a very short reply. 0.6. What is the ratio of the Gross enrolment ratio (%) in Pre-primary schools in Sub-Saharan Africa (all income levels) to that in Sub-Saharan Africa (developing only)?
Your response must be concise. 1. What is the ratio of the Gross enrolment ratio (%) in Pre-primary schools in Sub-Saharan Africa (all income levels) to that in Upper middle income?
Offer a very short reply. 0.3. What is the ratio of the Gross enrolment ratio (%) of Primary schools in Sub-Saharan Africa (all income levels) to that in Upper middle income?
Ensure brevity in your answer.  0.79. What is the ratio of the Gross enrolment ratio (%) in Secondary schools in Sub-Saharan Africa (all income levels) to that in Upper middle income?
Your answer should be compact. 0.42. What is the ratio of the Gross enrolment ratio (%) in Tertiary schools in Sub-Saharan Africa (all income levels) to that in Upper middle income?
Your answer should be compact. 0.3. What is the ratio of the Gross enrolment ratio (%) in Pre-primary schools in Sub-Saharan Africa (all income levels) to that in World?
Provide a short and direct response. 0.37. What is the ratio of the Gross enrolment ratio (%) in Primary schools in Sub-Saharan Africa (all income levels) to that in World?
Your answer should be compact. 0.87. What is the ratio of the Gross enrolment ratio (%) in Secondary schools in Sub-Saharan Africa (all income levels) to that in World?
Your answer should be compact. 0.47. What is the ratio of the Gross enrolment ratio (%) in Tertiary schools in Sub-Saharan Africa (all income levels) to that in World?
Give a very brief answer. 0.24. What is the ratio of the Gross enrolment ratio (%) of Pre-primary schools in Sub-Saharan Africa (all income levels) to that in Albania?
Your response must be concise. 0.32. What is the ratio of the Gross enrolment ratio (%) in Primary schools in Sub-Saharan Africa (all income levels) to that in Albania?
Provide a succinct answer. 1.25. What is the ratio of the Gross enrolment ratio (%) of Secondary schools in Sub-Saharan Africa (all income levels) to that in Albania?
Your answer should be compact. 0.4. What is the ratio of the Gross enrolment ratio (%) in Tertiary schools in Sub-Saharan Africa (all income levels) to that in Albania?
Your answer should be very brief. 0.36. What is the ratio of the Gross enrolment ratio (%) in Pre-primary schools in Sub-Saharan Africa (developing only) to that in Upper middle income?
Provide a succinct answer. 0.3. What is the ratio of the Gross enrolment ratio (%) in Primary schools in Sub-Saharan Africa (developing only) to that in Upper middle income?
Your response must be concise. 0.79. What is the ratio of the Gross enrolment ratio (%) in Secondary schools in Sub-Saharan Africa (developing only) to that in Upper middle income?
Ensure brevity in your answer.  0.42. What is the ratio of the Gross enrolment ratio (%) of Tertiary schools in Sub-Saharan Africa (developing only) to that in Upper middle income?
Ensure brevity in your answer.  0.3. What is the ratio of the Gross enrolment ratio (%) of Pre-primary schools in Sub-Saharan Africa (developing only) to that in World?
Your response must be concise. 0.37. What is the ratio of the Gross enrolment ratio (%) in Primary schools in Sub-Saharan Africa (developing only) to that in World?
Ensure brevity in your answer.  0.87. What is the ratio of the Gross enrolment ratio (%) in Secondary schools in Sub-Saharan Africa (developing only) to that in World?
Your answer should be compact. 0.47. What is the ratio of the Gross enrolment ratio (%) of Tertiary schools in Sub-Saharan Africa (developing only) to that in World?
Make the answer very short. 0.24. What is the ratio of the Gross enrolment ratio (%) of Pre-primary schools in Sub-Saharan Africa (developing only) to that in Albania?
Offer a very short reply. 0.32. What is the ratio of the Gross enrolment ratio (%) in Primary schools in Sub-Saharan Africa (developing only) to that in Albania?
Offer a terse response. 1.25. What is the ratio of the Gross enrolment ratio (%) of Secondary schools in Sub-Saharan Africa (developing only) to that in Albania?
Keep it short and to the point. 0.4. What is the ratio of the Gross enrolment ratio (%) in Tertiary schools in Sub-Saharan Africa (developing only) to that in Albania?
Your response must be concise. 0.36. What is the ratio of the Gross enrolment ratio (%) of Pre-primary schools in Upper middle income to that in World?
Keep it short and to the point. 1.22. What is the ratio of the Gross enrolment ratio (%) in Primary schools in Upper middle income to that in World?
Your answer should be compact. 1.1. What is the ratio of the Gross enrolment ratio (%) in Secondary schools in Upper middle income to that in World?
Give a very brief answer. 1.12. What is the ratio of the Gross enrolment ratio (%) in Tertiary schools in Upper middle income to that in World?
Provide a succinct answer. 0.82. What is the ratio of the Gross enrolment ratio (%) in Pre-primary schools in Upper middle income to that in Albania?
Your response must be concise. 1.06. What is the ratio of the Gross enrolment ratio (%) of Primary schools in Upper middle income to that in Albania?
Provide a succinct answer. 1.58. What is the ratio of the Gross enrolment ratio (%) in Tertiary schools in Upper middle income to that in Albania?
Your answer should be very brief. 1.2. What is the ratio of the Gross enrolment ratio (%) of Pre-primary schools in World to that in Albania?
Your answer should be very brief. 0.86. What is the ratio of the Gross enrolment ratio (%) of Primary schools in World to that in Albania?
Make the answer very short. 1.44. What is the ratio of the Gross enrolment ratio (%) of Secondary schools in World to that in Albania?
Make the answer very short. 0.85. What is the ratio of the Gross enrolment ratio (%) in Tertiary schools in World to that in Albania?
Your response must be concise. 1.46. What is the difference between the highest and the second highest Gross enrolment ratio (%) of Pre-primary schools?
Ensure brevity in your answer.  2.43. What is the difference between the highest and the second highest Gross enrolment ratio (%) of Primary schools?
Your response must be concise. 9.55. What is the difference between the highest and the second highest Gross enrolment ratio (%) of Secondary schools?
Ensure brevity in your answer.  3.08. What is the difference between the highest and the second highest Gross enrolment ratio (%) of Tertiary schools?
Provide a succinct answer. 3.87. What is the difference between the highest and the lowest Gross enrolment ratio (%) in Pre-primary schools?
Your response must be concise. 30.52. What is the difference between the highest and the lowest Gross enrolment ratio (%) of Primary schools?
Your response must be concise. 40.19. What is the difference between the highest and the lowest Gross enrolment ratio (%) in Secondary schools?
Your answer should be compact. 42.58. What is the difference between the highest and the lowest Gross enrolment ratio (%) of Tertiary schools?
Your answer should be very brief. 16.29. 